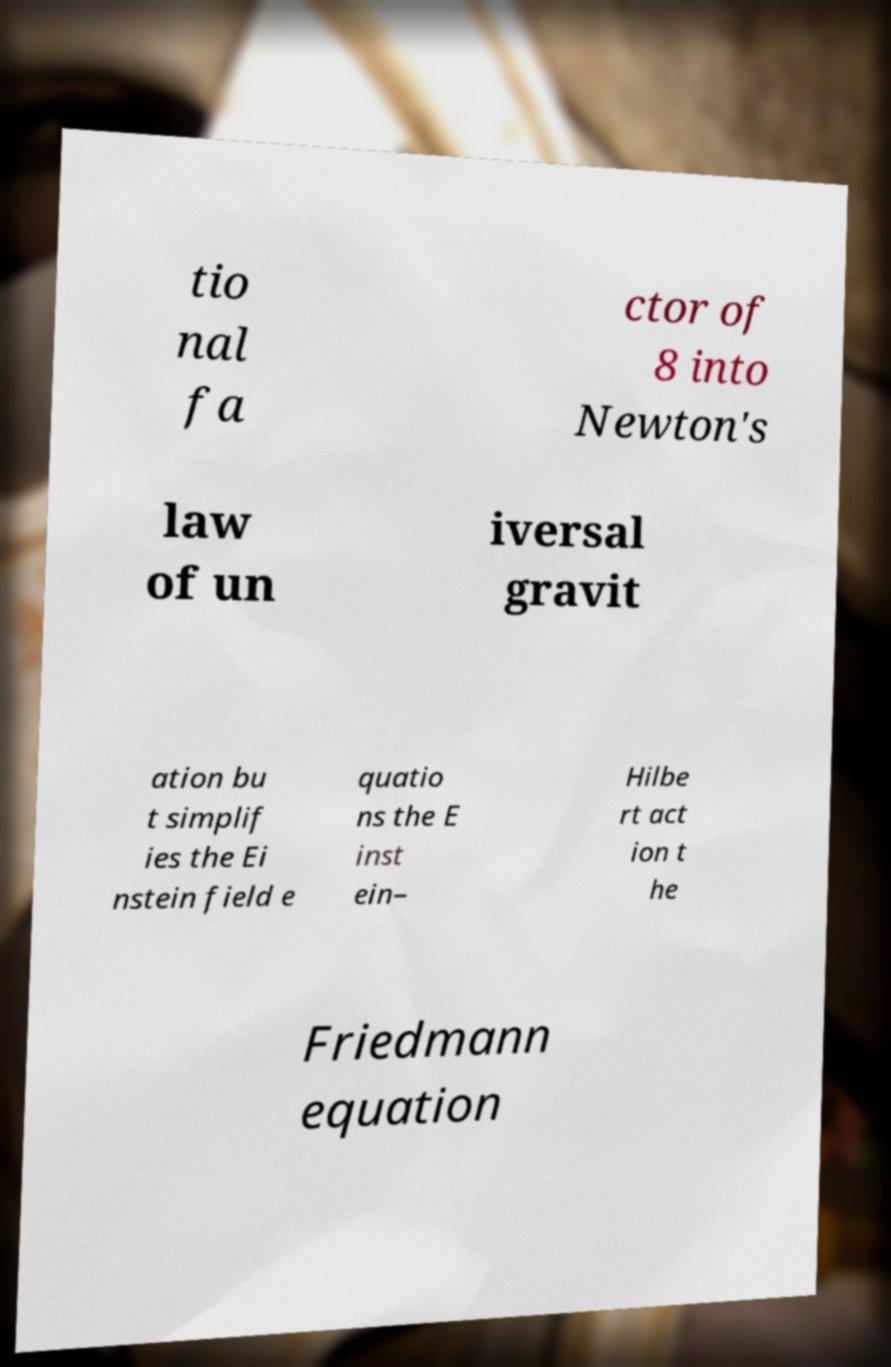Please read and relay the text visible in this image. What does it say? tio nal fa ctor of 8 into Newton's law of un iversal gravit ation bu t simplif ies the Ei nstein field e quatio ns the E inst ein– Hilbe rt act ion t he Friedmann equation 